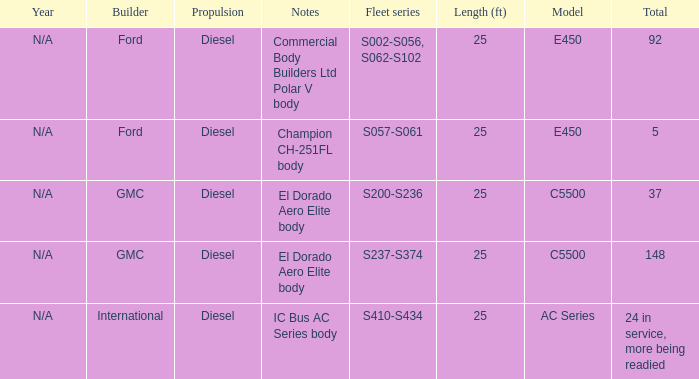What are the notes for Ford when the total is 5? Champion CH-251FL body. 